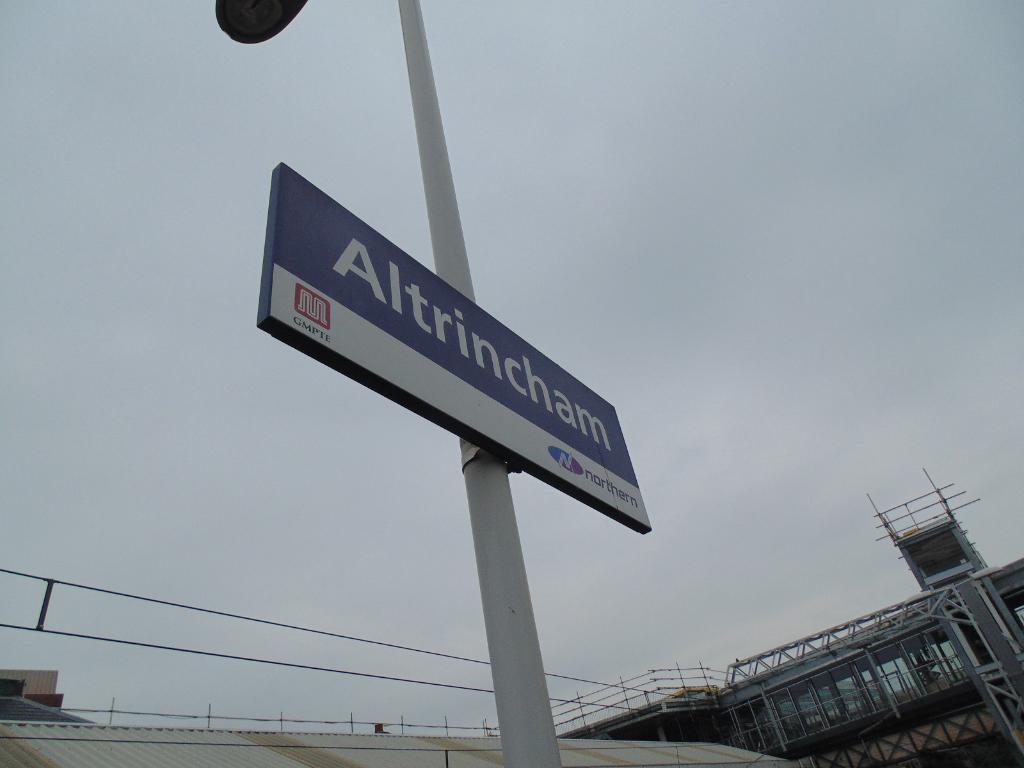Could you give a brief overview of what you see in this image? In this image there is a pole with a board. On the board something is written. At the bottom we can see buildings with rods and railings. In the background there is sky. 